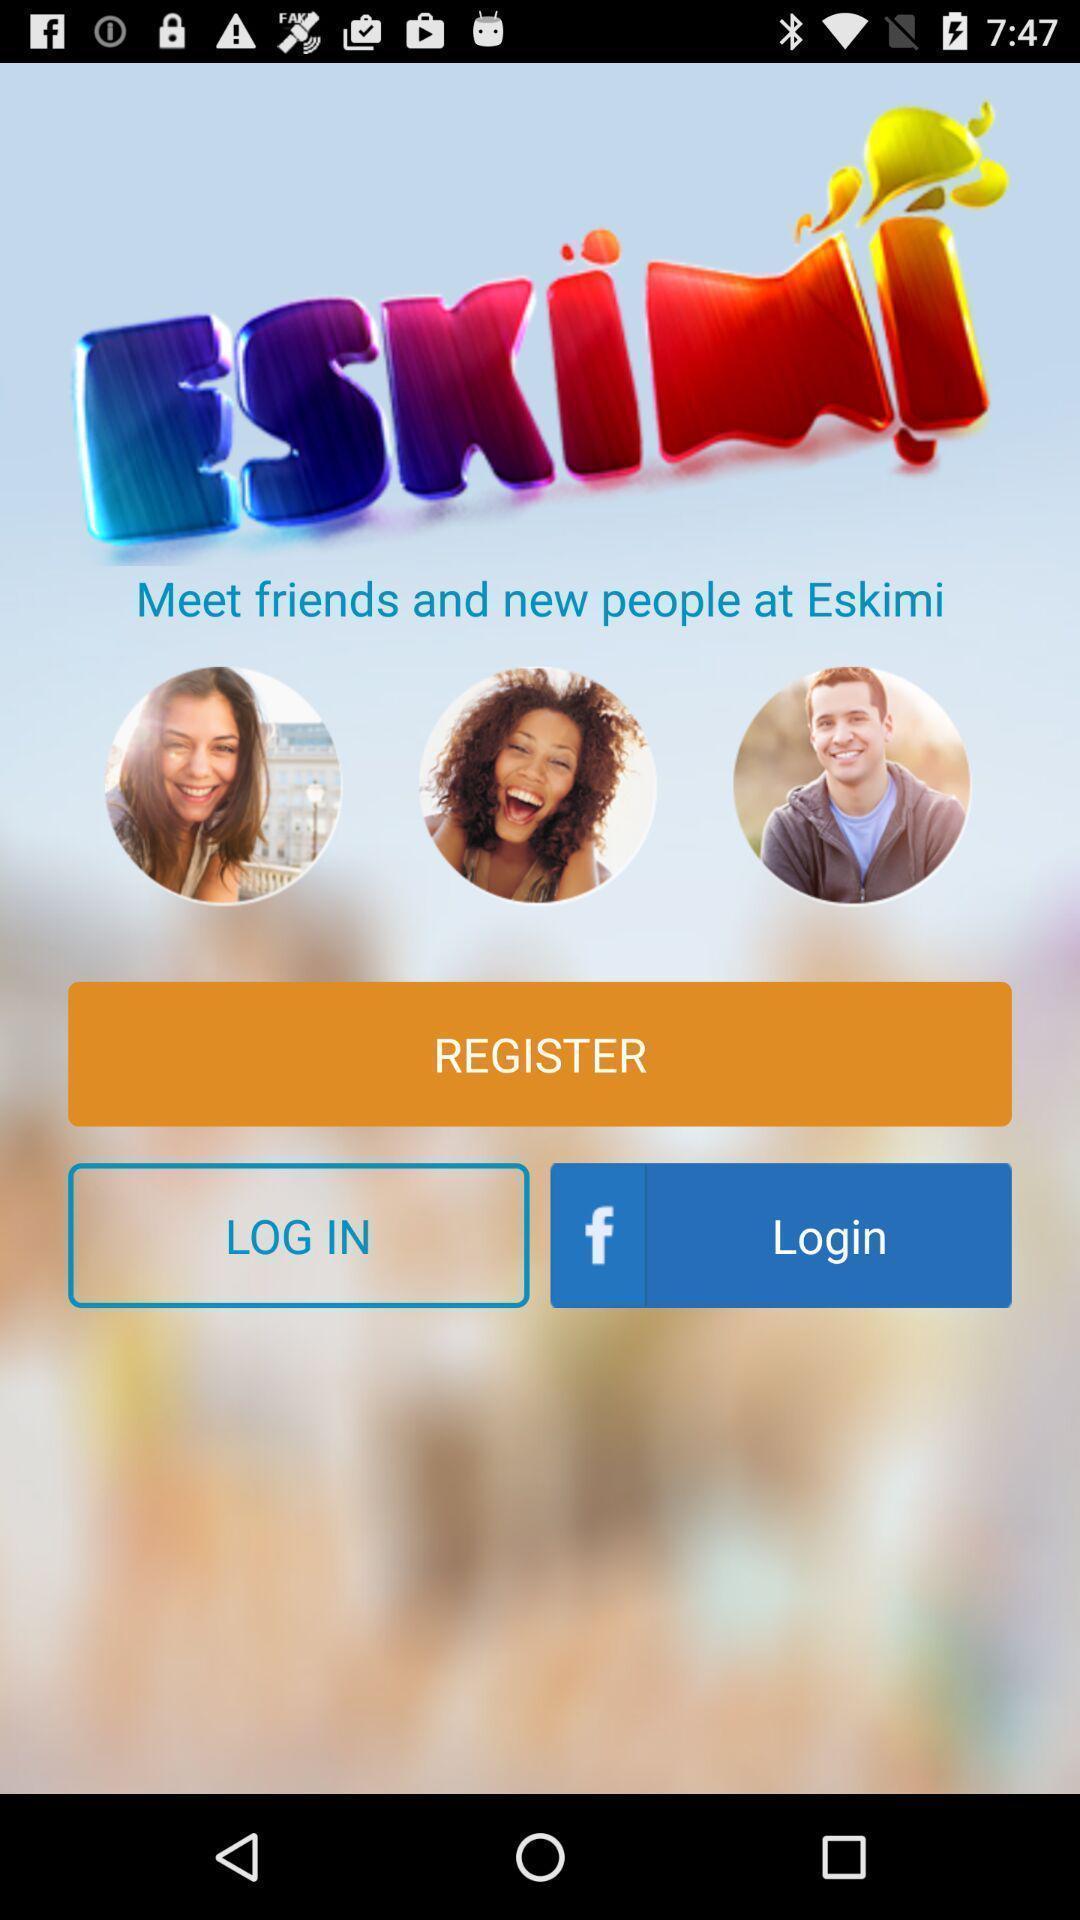Describe the visual elements of this screenshot. Register page. 